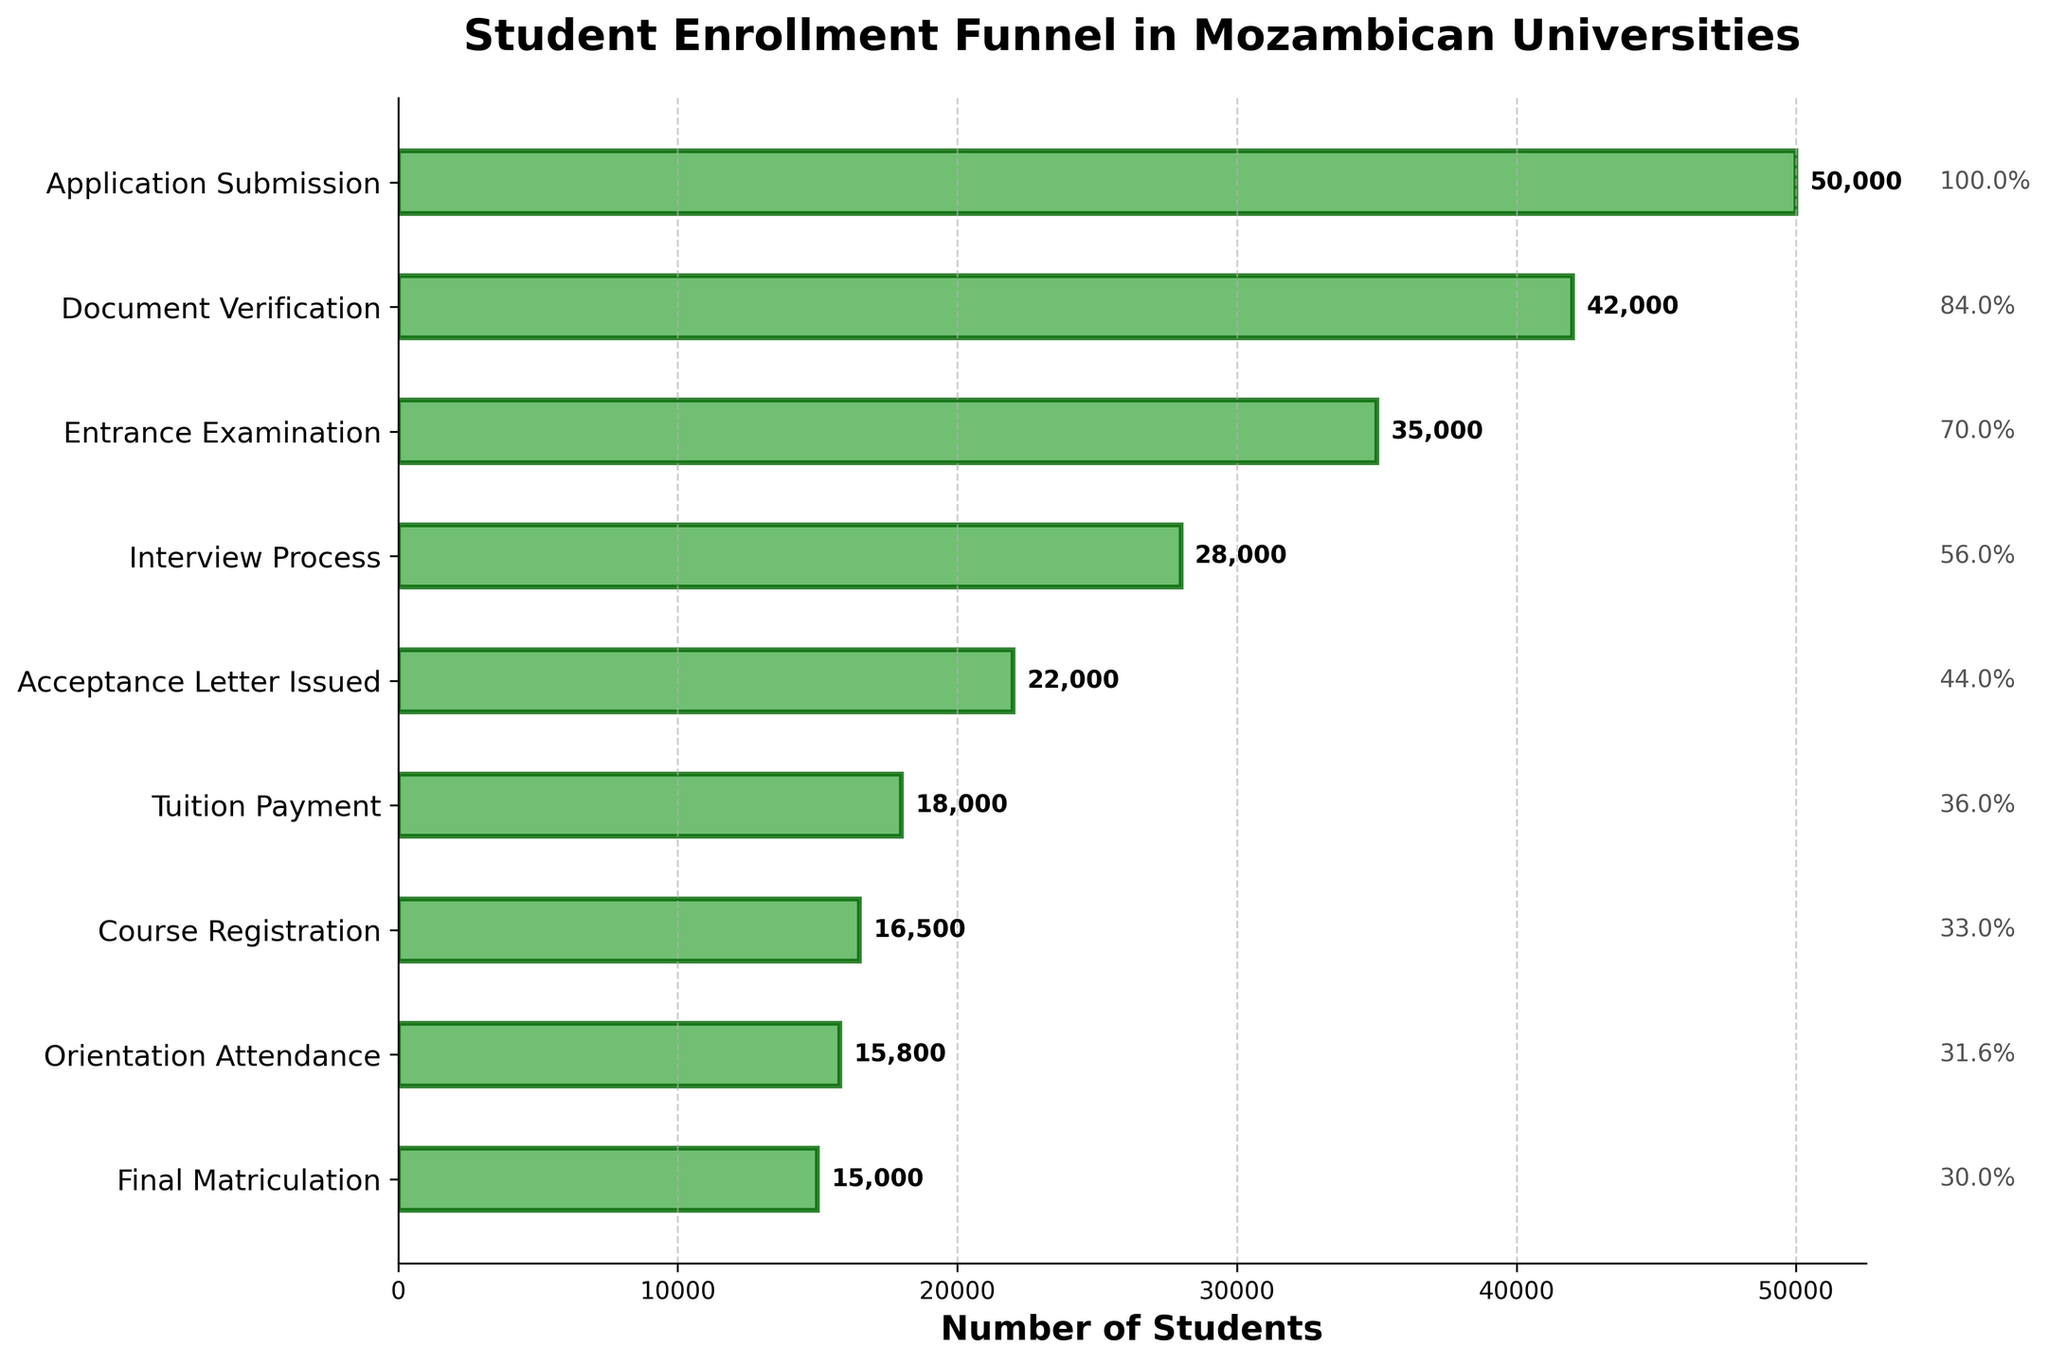What is the title of the figure? The title of the figure is located at the top and bolded in large font. It summarizes what the funnel chart represents.
Answer: Student Enrollment Funnel in Mozambican Universities Which stage has the highest number of students? The first bar at the top of the funnel chart is the widest and represents the stage with the highest number of students.
Answer: Application Submission How many stages are there in the funnel chart? You can count the number of horizontal bars to determine the number of stages in the funnel chart.
Answer: 9 What is the percentage of students that reach Final Matriculation compared to Application Submission? Percentage is calculated by dividing the number of students at Final Matriculation by the number of students at Application Submission and then multiplying by 100.
Answer: 15000 / 50000 * 100 = 30% Which two stages have the smallest difference in the number of students? To find this, you compare the differences in the number of students between consecutive stages and identify the smallest difference.
Answer: Orientation Attendance and Final Matriculation How many students drop off between Acceptance Letter Issued and Tuition Payment? To find this, you subtract the number of students at Tuition Payment from the number of students at Acceptance Letter Issued.
Answer: 22000 - 18000 = 4000 How does the number of students decrease from Document Verification to Entrance Examination? You subtract the number of students in Entrance Examination from the number of students in Document Verification.
Answer: 42000 - 35000 = 7000 Is the reduction in the number of students larger between Entrance Examination to Interview Process or Interview Process to Acceptance Letter Issued? You calculate the reductions for both intervals and compare them.
Answer: Entrance Examination to Interview Process: 35000 - 28000 = 7000. Interview Process to Acceptance Letter Issued: 28000 - 22000 = 6000. Reduction is larger between Entrance Examination to Interview Process What is the average number of students across all stages? Sum the number of students at each stage and divide by the total number of stages.
Answer: (50000 + 42000 + 35000 + 28000 + 22000 + 18000 + 16500 + 15800 + 15000) / 9 = 26889 Which stage contributes the most to dropout rates? By visually comparing the widths of the bars and calculating the differences, you can see which stage has the most significant reduction in numbers.
Answer: Entrance Examination 